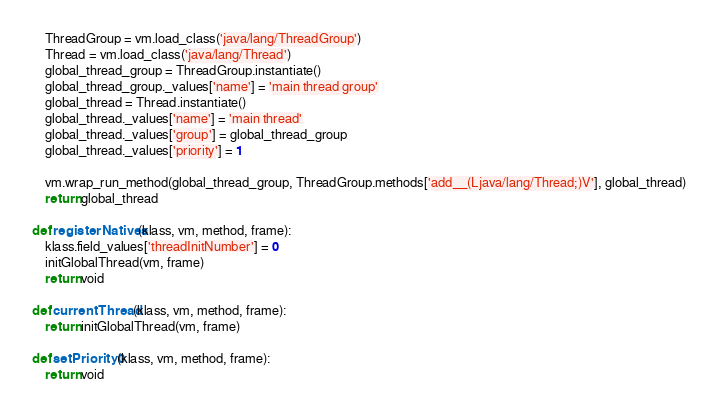<code> <loc_0><loc_0><loc_500><loc_500><_Python_>    ThreadGroup = vm.load_class('java/lang/ThreadGroup')
    Thread = vm.load_class('java/lang/Thread')
    global_thread_group = ThreadGroup.instantiate()
    global_thread_group._values['name'] = 'main thread group'
    global_thread = Thread.instantiate()
    global_thread._values['name'] = 'main thread'
    global_thread._values['group'] = global_thread_group
    global_thread._values['priority'] = 1

    vm.wrap_run_method(global_thread_group, ThreadGroup.methods['add__(Ljava/lang/Thread;)V'], global_thread)
    return global_thread

def registerNatives(klass, vm, method, frame):
    klass.field_values['threadInitNumber'] = 0
    initGlobalThread(vm, frame)
    return void

def currentThread(klass, vm, method, frame):
    return initGlobalThread(vm, frame)

def setPriority0(klass, vm, method, frame):
    return void
</code> 